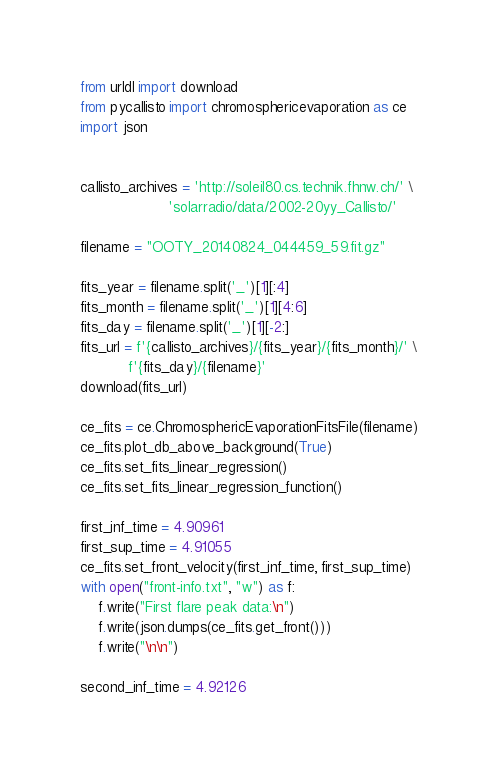<code> <loc_0><loc_0><loc_500><loc_500><_Python_>from urldl import download
from pycallisto import chromosphericevaporation as ce
import json


callisto_archives = 'http://soleil80.cs.technik.fhnw.ch/' \
                    'solarradio/data/2002-20yy_Callisto/'

filename = "OOTY_20140824_044459_59.fit.gz"

fits_year = filename.split('_')[1][:4]
fits_month = filename.split('_')[1][4:6]
fits_day = filename.split('_')[1][-2:]
fits_url = f'{callisto_archives}/{fits_year}/{fits_month}/' \
           f'{fits_day}/{filename}'
download(fits_url)

ce_fits = ce.ChromosphericEvaporationFitsFile(filename)
ce_fits.plot_db_above_background(True)
ce_fits.set_fits_linear_regression()
ce_fits.set_fits_linear_regression_function()

first_inf_time = 4.90961
first_sup_time = 4.91055
ce_fits.set_front_velocity(first_inf_time, first_sup_time)
with open("front-info.txt", "w") as f:
    f.write("First flare peak data:\n")
    f.write(json.dumps(ce_fits.get_front()))
    f.write("\n\n")

second_inf_time = 4.92126</code> 